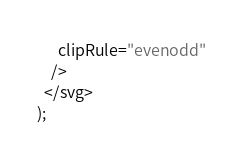Convert code to text. <code><loc_0><loc_0><loc_500><loc_500><_TypeScript_>      clipRule="evenodd"
    />
  </svg>
);
</code> 